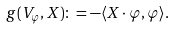<formula> <loc_0><loc_0><loc_500><loc_500>g ( V _ { \varphi } , X ) \colon = - \langle X \cdot \varphi , \varphi \rangle .</formula> 